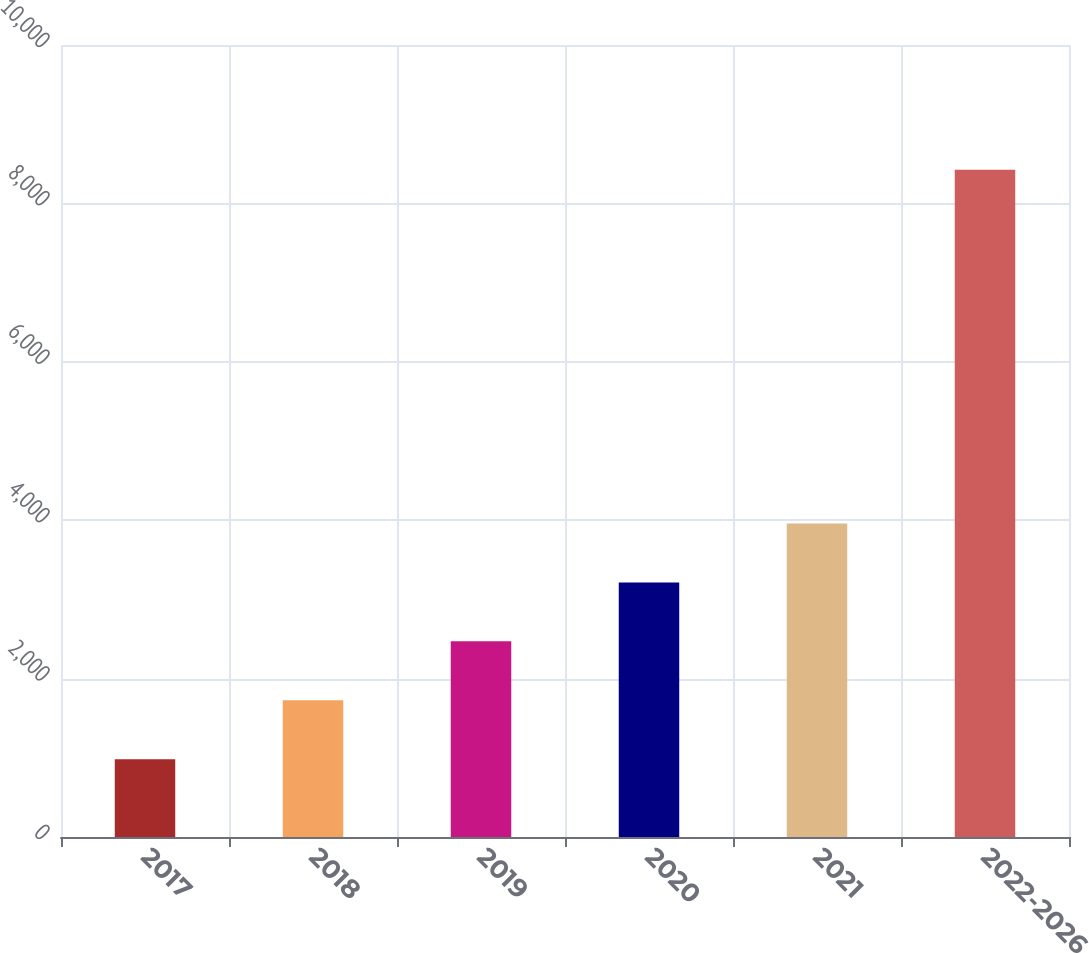Convert chart to OTSL. <chart><loc_0><loc_0><loc_500><loc_500><bar_chart><fcel>2017<fcel>2018<fcel>2019<fcel>2020<fcel>2021<fcel>2022-2026<nl><fcel>982<fcel>1726.2<fcel>2470.4<fcel>3214.6<fcel>3958.8<fcel>8424<nl></chart> 